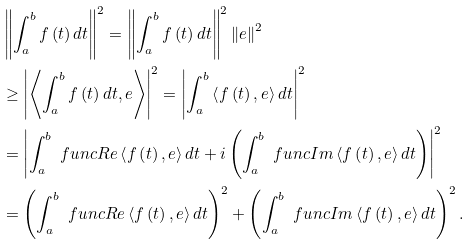Convert formula to latex. <formula><loc_0><loc_0><loc_500><loc_500>& \left \| \int _ { a } ^ { b } f \left ( t \right ) d t \right \| ^ { 2 } = \left \| \int _ { a } ^ { b } f \left ( t \right ) d t \right \| ^ { 2 } \left \| e \right \| ^ { 2 } \\ & \geq \left | \left \langle \int _ { a } ^ { b } f \left ( t \right ) d t , e \right \rangle \right | ^ { 2 } = \left | \int _ { a } ^ { b } \left \langle f \left ( t \right ) , e \right \rangle d t \right | ^ { 2 } \\ & = \left | \int _ { a } ^ { b } \ f u n c { R e } \left \langle f \left ( t \right ) , e \right \rangle d t + i \left ( \int _ { a } ^ { b } \ f u n c { I m } \left \langle f \left ( t \right ) , e \right \rangle d t \right ) \right | ^ { 2 } \\ & = \left ( \int _ { a } ^ { b } \ f u n c { R e } \left \langle f \left ( t \right ) , e \right \rangle d t \right ) ^ { 2 } + \left ( \int _ { a } ^ { b } \ f u n c { I m } \left \langle f \left ( t \right ) , e \right \rangle d t \right ) ^ { 2 } .</formula> 